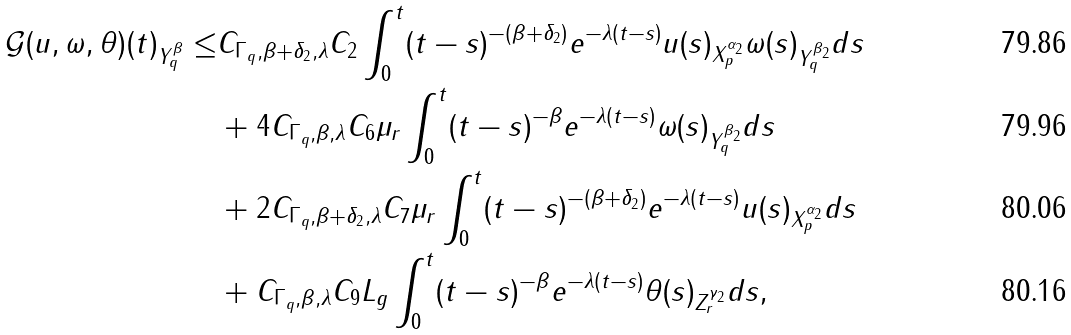Convert formula to latex. <formula><loc_0><loc_0><loc_500><loc_500>\| \mathcal { G } ( u , \omega , \theta ) ( t ) \| _ { Y ^ { \beta } _ { q } } \leq & C _ { \Gamma _ { q } , \beta + \delta _ { 2 } , \lambda } C _ { 2 } \int ^ { t } _ { 0 } ( t - s ) ^ { - ( \beta + \delta _ { 2 } ) } e ^ { - \lambda ( t - s ) } \| u ( s ) \| _ { X ^ { \alpha _ { 2 } } _ { p } } \| \omega ( s ) \| _ { Y ^ { \beta _ { 2 } } _ { q } } d s \\ & + 4 C _ { \Gamma _ { q } , \beta , \lambda } C _ { 6 } \mu _ { r } \int ^ { t } _ { 0 } ( t - s ) ^ { - \beta } e ^ { - \lambda ( t - s ) } \| \omega ( s ) \| _ { Y ^ { \beta _ { 2 } } _ { q } } d s \\ & + 2 C _ { \Gamma _ { q } , \beta + \delta _ { 2 } , \lambda } C _ { 7 } \mu _ { r } \int ^ { t } _ { 0 } ( t - s ) ^ { - ( \beta + \delta _ { 2 } ) } e ^ { - \lambda ( t - s ) } \| u ( s ) \| _ { X ^ { \alpha _ { 2 } } _ { p } } d s \\ & + C _ { \Gamma _ { q } , \beta , \lambda } C _ { 9 } L _ { g } \int ^ { t } _ { 0 } ( t - s ) ^ { - \beta } e ^ { - \lambda ( t - s ) } \| \theta ( s ) \| _ { Z ^ { \gamma _ { 2 } } _ { r } } d s ,</formula> 